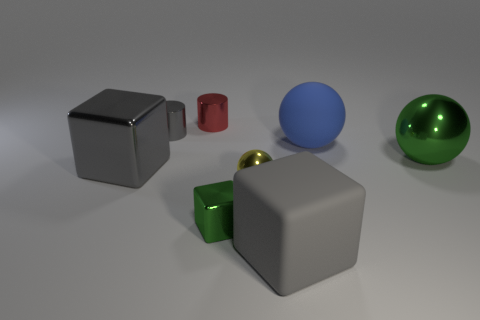Add 1 gray matte objects. How many objects exist? 9 Subtract all small gray metal things. Subtract all metallic spheres. How many objects are left? 5 Add 6 small red shiny cylinders. How many small red shiny cylinders are left? 7 Add 8 small metallic cylinders. How many small metallic cylinders exist? 10 Subtract 0 cyan cylinders. How many objects are left? 8 Subtract all cylinders. How many objects are left? 6 